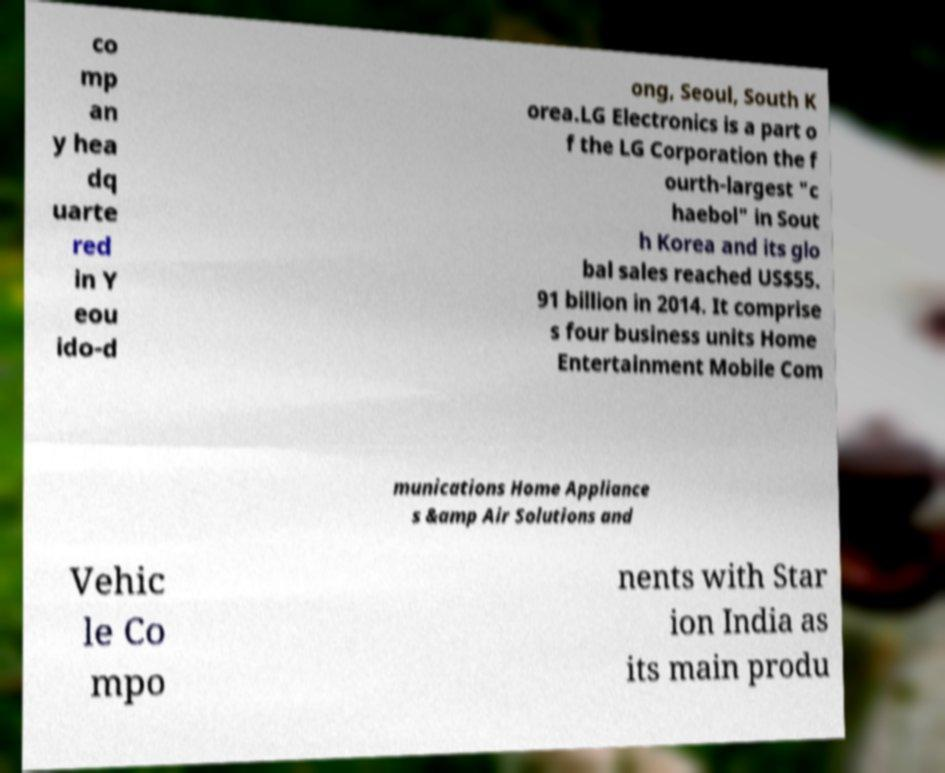There's text embedded in this image that I need extracted. Can you transcribe it verbatim? co mp an y hea dq uarte red in Y eou ido-d ong, Seoul, South K orea.LG Electronics is a part o f the LG Corporation the f ourth-largest "c haebol" in Sout h Korea and its glo bal sales reached US$55. 91 billion in 2014. It comprise s four business units Home Entertainment Mobile Com munications Home Appliance s &amp Air Solutions and Vehic le Co mpo nents with Star ion India as its main produ 